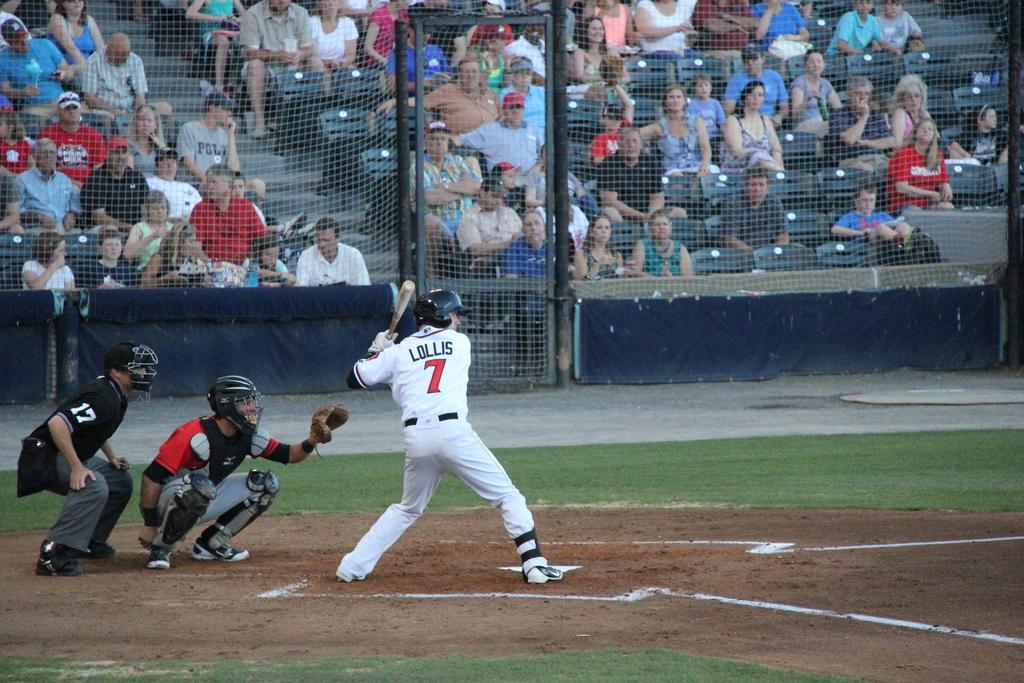<image>
Provide a brief description of the given image. A batman at the plate, jersey reading Lollis 7, along with the catcher and another person. 